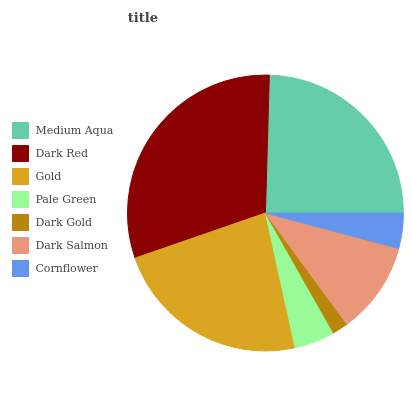Is Dark Gold the minimum?
Answer yes or no. Yes. Is Dark Red the maximum?
Answer yes or no. Yes. Is Gold the minimum?
Answer yes or no. No. Is Gold the maximum?
Answer yes or no. No. Is Dark Red greater than Gold?
Answer yes or no. Yes. Is Gold less than Dark Red?
Answer yes or no. Yes. Is Gold greater than Dark Red?
Answer yes or no. No. Is Dark Red less than Gold?
Answer yes or no. No. Is Dark Salmon the high median?
Answer yes or no. Yes. Is Dark Salmon the low median?
Answer yes or no. Yes. Is Dark Gold the high median?
Answer yes or no. No. Is Dark Gold the low median?
Answer yes or no. No. 